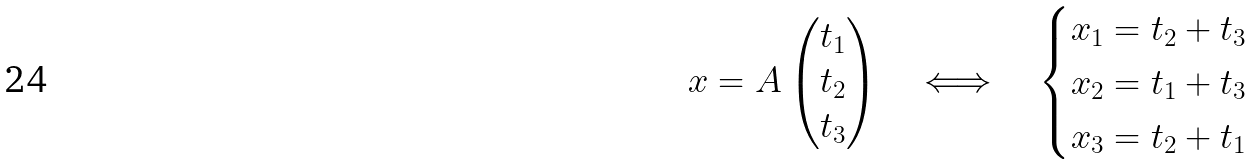<formula> <loc_0><loc_0><loc_500><loc_500>x = A \begin{pmatrix} t _ { 1 } \\ t _ { 2 } \\ t _ { 3 } \end{pmatrix} \quad \Longleftrightarrow \quad \begin{cases} x _ { 1 } = t _ { 2 } + t _ { 3 } \\ x _ { 2 } = t _ { 1 } + t _ { 3 } \\ x _ { 3 } = t _ { 2 } + t _ { 1 } \end{cases}</formula> 